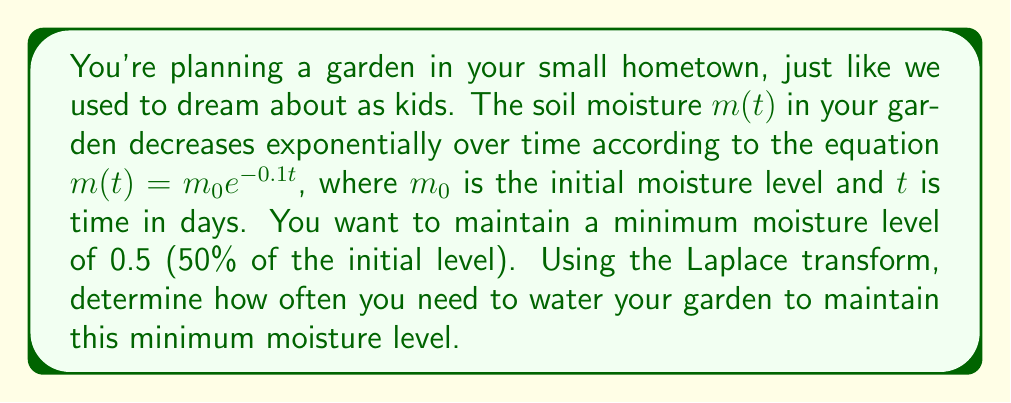Give your solution to this math problem. Let's approach this step-by-step using the Laplace transform:

1) First, we need to find the Laplace transform of the moisture function:
   $$\mathcal{L}\{m(t)\} = \mathcal{L}\{m_0e^{-0.1t}\} = \frac{m_0}{s + 0.1}$$

2) We want to find the time $T$ when the moisture level reaches 0.5$m_0$:
   $$0.5m_0 = m_0e^{-0.1T}$$

3) Solving for $T$:
   $$0.5 = e^{-0.1T}$$
   $$\ln(0.5) = -0.1T$$
   $$T = \frac{-\ln(0.5)}{0.1} \approx 6.93 \text{ days}$$

4) This means you need to water your garden every 6.93 days to maintain the minimum moisture level.

5) To verify this using the Laplace transform, we can model the watering as a periodic impulse function with period $T$:
   $$w(t) = m_0\sum_{n=0}^{\infty}\delta(t-nT)$$

6) The Laplace transform of this watering function is:
   $$\mathcal{L}\{w(t)\} = m_0\frac{1}{1-e^{-sT}}$$

7) The total moisture in the garden will be the sum of the initial moisture and all subsequent waterings:
   $$M(s) = \frac{m_0}{s + 0.1} + \frac{m_0}{s + 0.1}\cdot\frac{1}{1-e^{-sT}}$$

8) For the moisture to always be above 0.5$m_0$, we need:
   $$\lim_{s \to 0} sM(s) \geq 0.5m_0$$

9) Evaluating this limit:
   $$\lim_{s \to 0} \frac{m_0}{1 + 0.1/s} + \frac{m_0}{1 + 0.1/s}\cdot\frac{1}{1-e^{-sT}} = m_0\left(1 + \frac{1}{e^{0.1T}-1}\right) \geq 0.5m_0$$

10) This inequality is satisfied when $T \approx 6.93$ days, confirming our earlier calculation.
Answer: You need to water your garden every 6.93 days to maintain a minimum moisture level of 50% of the initial level. 